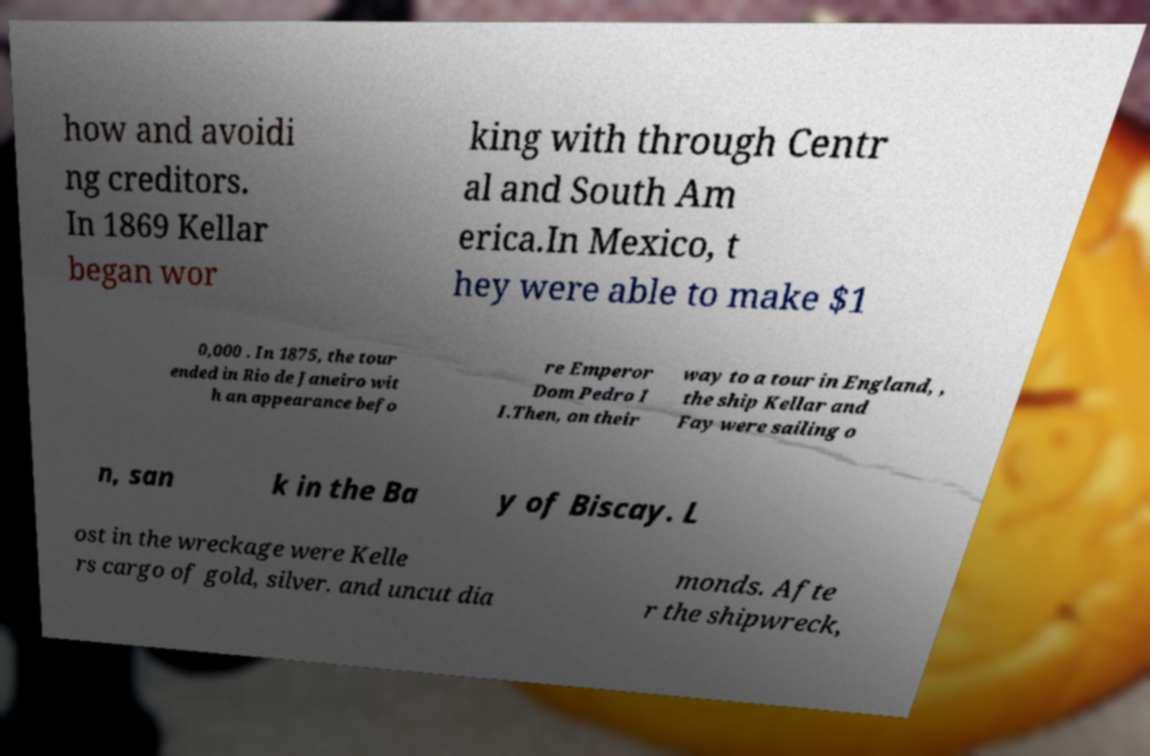There's text embedded in this image that I need extracted. Can you transcribe it verbatim? how and avoidi ng creditors. In 1869 Kellar began wor king with through Centr al and South Am erica.In Mexico, t hey were able to make $1 0,000 . In 1875, the tour ended in Rio de Janeiro wit h an appearance befo re Emperor Dom Pedro I I.Then, on their way to a tour in England, , the ship Kellar and Fay were sailing o n, san k in the Ba y of Biscay. L ost in the wreckage were Kelle rs cargo of gold, silver. and uncut dia monds. Afte r the shipwreck, 